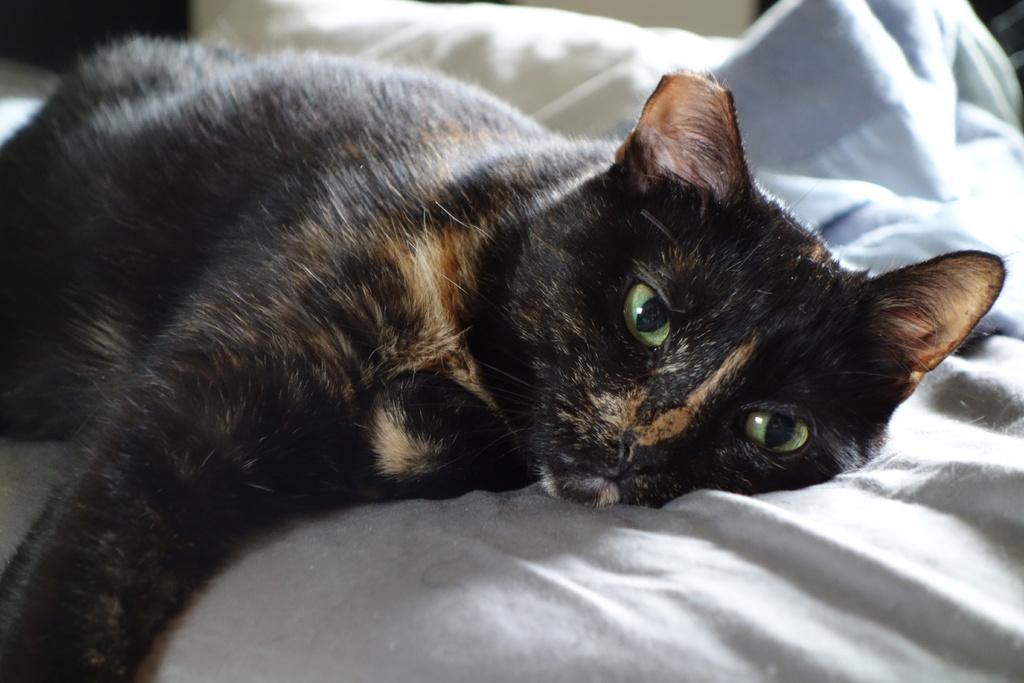In one or two sentences, can you explain what this image depicts? In this image, we can see a black color cat on the bed. 